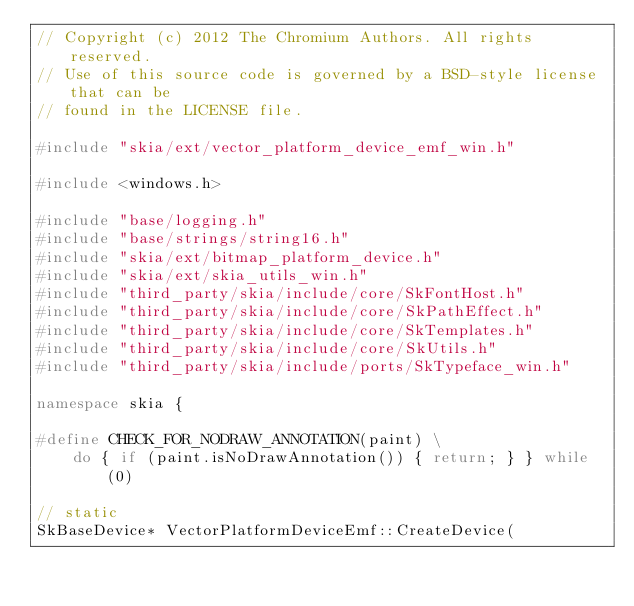<code> <loc_0><loc_0><loc_500><loc_500><_C++_>// Copyright (c) 2012 The Chromium Authors. All rights reserved.
// Use of this source code is governed by a BSD-style license that can be
// found in the LICENSE file.

#include "skia/ext/vector_platform_device_emf_win.h"

#include <windows.h>

#include "base/logging.h"
#include "base/strings/string16.h"
#include "skia/ext/bitmap_platform_device.h"
#include "skia/ext/skia_utils_win.h"
#include "third_party/skia/include/core/SkFontHost.h"
#include "third_party/skia/include/core/SkPathEffect.h"
#include "third_party/skia/include/core/SkTemplates.h"
#include "third_party/skia/include/core/SkUtils.h"
#include "third_party/skia/include/ports/SkTypeface_win.h"

namespace skia {

#define CHECK_FOR_NODRAW_ANNOTATION(paint) \
    do { if (paint.isNoDrawAnnotation()) { return; } } while (0)

// static
SkBaseDevice* VectorPlatformDeviceEmf::CreateDevice(</code> 